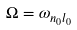Convert formula to latex. <formula><loc_0><loc_0><loc_500><loc_500>\Omega = \omega _ { n _ { 0 } l _ { 0 } }</formula> 